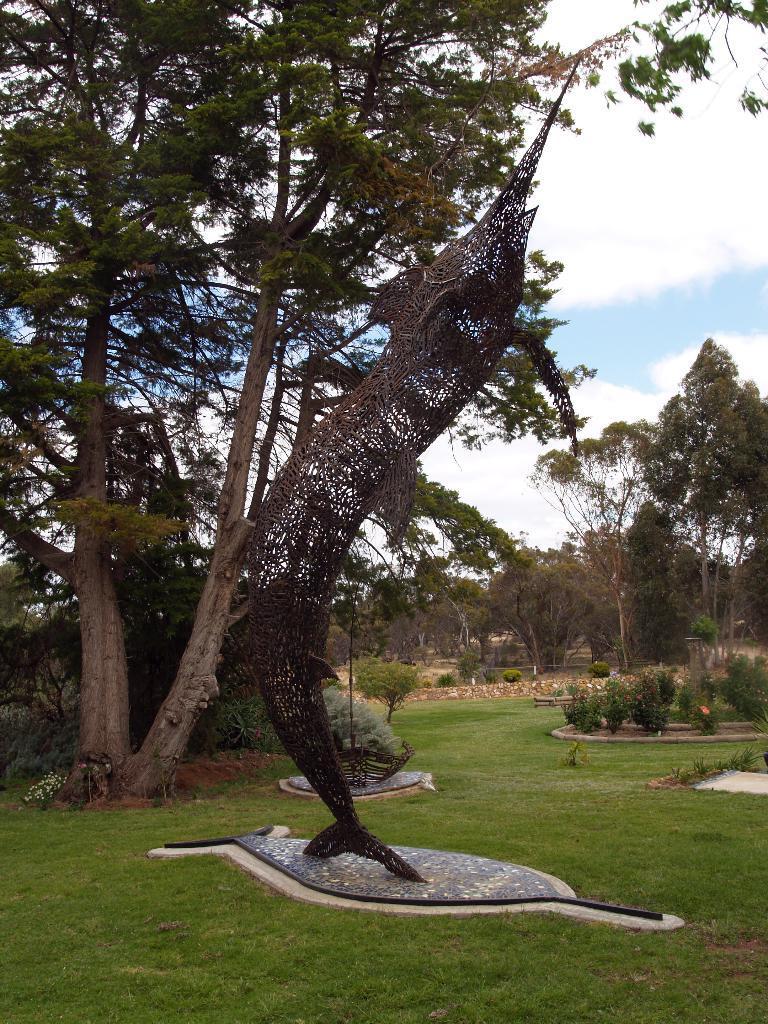Please provide a concise description of this image. In this image I can see some grass, a structure which is black in color, few trees and few plants. In the background I can see the sky. 